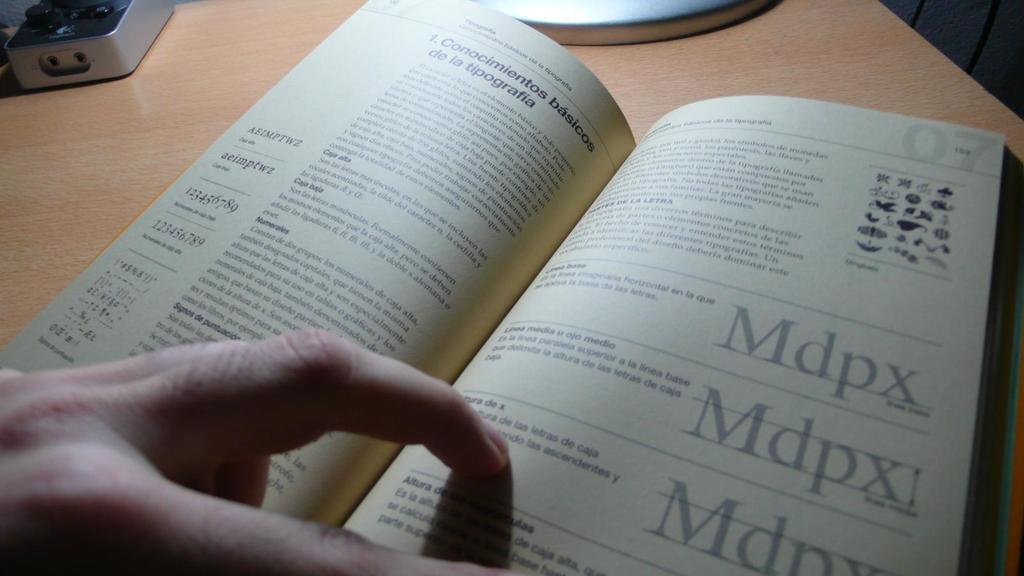Provide a one-sentence caption for the provided image. A text book writen in a foreign language with Mdpx repeated on the page. 